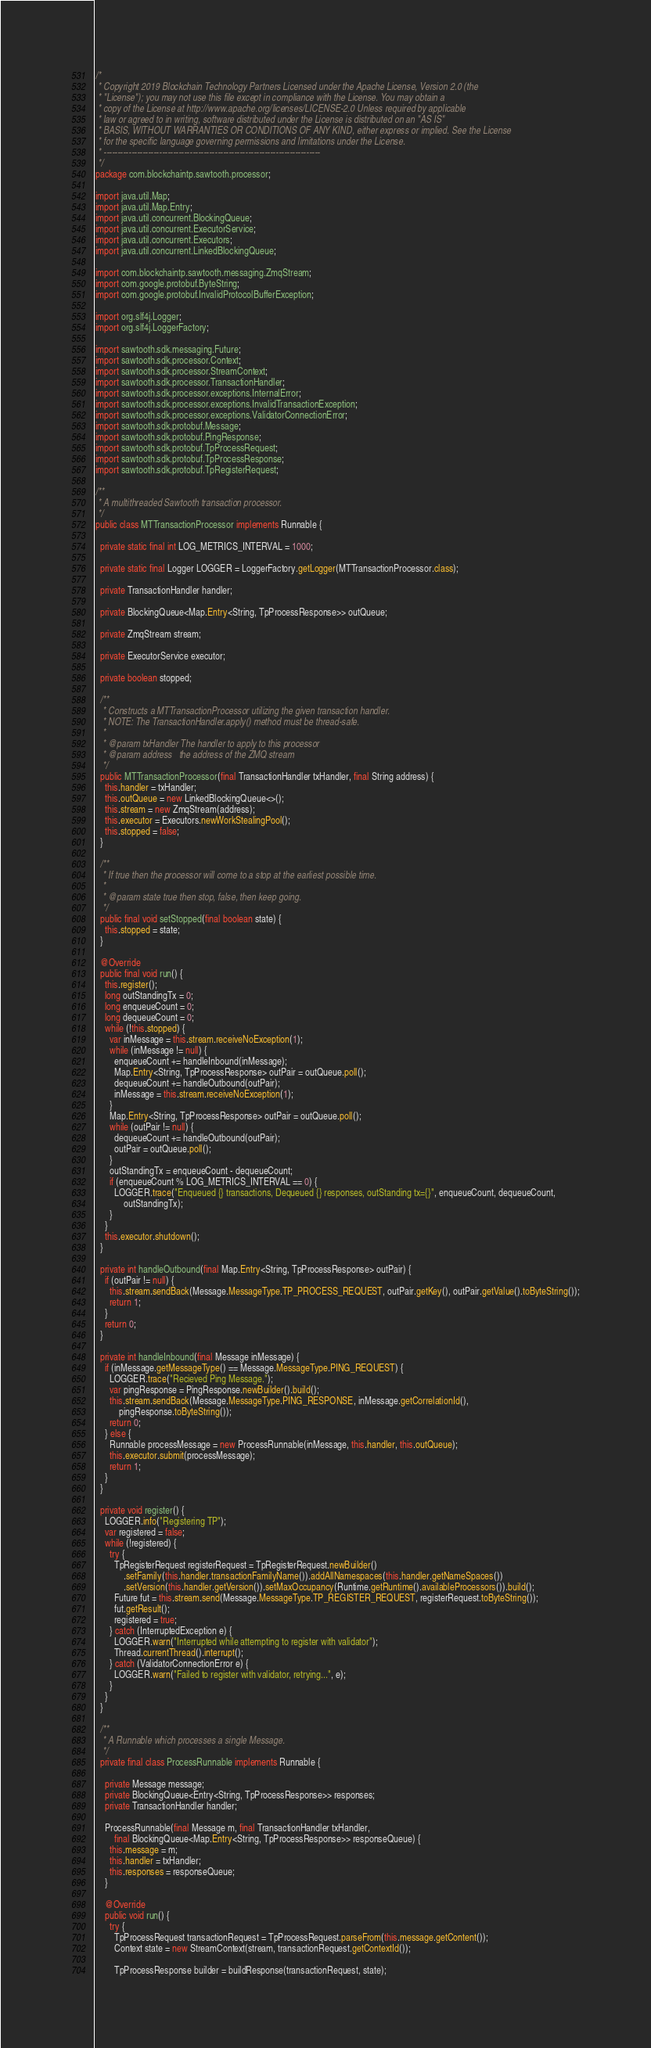<code> <loc_0><loc_0><loc_500><loc_500><_Java_>/*
 * Copyright 2019 Blockchain Technology Partners Licensed under the Apache License, Version 2.0 (the
 * "License"); you may not use this file except in compliance with the License. You may obtain a
 * copy of the License at http://www.apache.org/licenses/LICENSE-2.0 Unless required by applicable
 * law or agreed to in writing, software distributed under the License is distributed on an "AS IS"
 * BASIS, WITHOUT WARRANTIES OR CONDITIONS OF ANY KIND, either express or implied. See the License
 * for the specific language governing permissions and limitations under the License.
 * ------------------------------------------------------------------------------
 */
package com.blockchaintp.sawtooth.processor;

import java.util.Map;
import java.util.Map.Entry;
import java.util.concurrent.BlockingQueue;
import java.util.concurrent.ExecutorService;
import java.util.concurrent.Executors;
import java.util.concurrent.LinkedBlockingQueue;

import com.blockchaintp.sawtooth.messaging.ZmqStream;
import com.google.protobuf.ByteString;
import com.google.protobuf.InvalidProtocolBufferException;

import org.slf4j.Logger;
import org.slf4j.LoggerFactory;

import sawtooth.sdk.messaging.Future;
import sawtooth.sdk.processor.Context;
import sawtooth.sdk.processor.StreamContext;
import sawtooth.sdk.processor.TransactionHandler;
import sawtooth.sdk.processor.exceptions.InternalError;
import sawtooth.sdk.processor.exceptions.InvalidTransactionException;
import sawtooth.sdk.processor.exceptions.ValidatorConnectionError;
import sawtooth.sdk.protobuf.Message;
import sawtooth.sdk.protobuf.PingResponse;
import sawtooth.sdk.protobuf.TpProcessRequest;
import sawtooth.sdk.protobuf.TpProcessResponse;
import sawtooth.sdk.protobuf.TpRegisterRequest;

/**
 * A multithreaded Sawtooth transaction processor.
 */
public class MTTransactionProcessor implements Runnable {

  private static final int LOG_METRICS_INTERVAL = 1000;

  private static final Logger LOGGER = LoggerFactory.getLogger(MTTransactionProcessor.class);

  private TransactionHandler handler;

  private BlockingQueue<Map.Entry<String, TpProcessResponse>> outQueue;

  private ZmqStream stream;

  private ExecutorService executor;

  private boolean stopped;

  /**
   * Constructs a MTTransactionProcessor utilizing the given transaction handler.
   * NOTE: The TransactionHandler.apply() method must be thread-safe.
   *
   * @param txHandler The handler to apply to this processor
   * @param address   the address of the ZMQ stream
   */
  public MTTransactionProcessor(final TransactionHandler txHandler, final String address) {
    this.handler = txHandler;
    this.outQueue = new LinkedBlockingQueue<>();
    this.stream = new ZmqStream(address);
    this.executor = Executors.newWorkStealingPool();
    this.stopped = false;
  }

  /**
   * If true then the processor will come to a stop at the earliest possible time.
   *
   * @param state true then stop, false, then keep going.
   */
  public final void setStopped(final boolean state) {
    this.stopped = state;
  }

  @Override
  public final void run() {
    this.register();
    long outStandingTx = 0;
    long enqueueCount = 0;
    long dequeueCount = 0;
    while (!this.stopped) {
      var inMessage = this.stream.receiveNoException(1);
      while (inMessage != null) {
        enqueueCount += handleInbound(inMessage);
        Map.Entry<String, TpProcessResponse> outPair = outQueue.poll();
        dequeueCount += handleOutbound(outPair);
        inMessage = this.stream.receiveNoException(1);
      }
      Map.Entry<String, TpProcessResponse> outPair = outQueue.poll();
      while (outPair != null) {
        dequeueCount += handleOutbound(outPair);
        outPair = outQueue.poll();
      }
      outStandingTx = enqueueCount - dequeueCount;
      if (enqueueCount % LOG_METRICS_INTERVAL == 0) {
        LOGGER.trace("Enqueued {} transactions, Dequeued {} responses, outStanding tx={}", enqueueCount, dequeueCount,
            outStandingTx);
      }
    }
    this.executor.shutdown();
  }

  private int handleOutbound(final Map.Entry<String, TpProcessResponse> outPair) {
    if (outPair != null) {
      this.stream.sendBack(Message.MessageType.TP_PROCESS_REQUEST, outPair.getKey(), outPair.getValue().toByteString());
      return 1;
    }
    return 0;
  }

  private int handleInbound(final Message inMessage) {
    if (inMessage.getMessageType() == Message.MessageType.PING_REQUEST) {
      LOGGER.trace("Recieved Ping Message.");
      var pingResponse = PingResponse.newBuilder().build();
      this.stream.sendBack(Message.MessageType.PING_RESPONSE, inMessage.getCorrelationId(),
          pingResponse.toByteString());
      return 0;
    } else {
      Runnable processMessage = new ProcessRunnable(inMessage, this.handler, this.outQueue);
      this.executor.submit(processMessage);
      return 1;
    }
  }

  private void register() {
    LOGGER.info("Registering TP");
    var registered = false;
    while (!registered) {
      try {
        TpRegisterRequest registerRequest = TpRegisterRequest.newBuilder()
            .setFamily(this.handler.transactionFamilyName()).addAllNamespaces(this.handler.getNameSpaces())
            .setVersion(this.handler.getVersion()).setMaxOccupancy(Runtime.getRuntime().availableProcessors()).build();
        Future fut = this.stream.send(Message.MessageType.TP_REGISTER_REQUEST, registerRequest.toByteString());
        fut.getResult();
        registered = true;
      } catch (InterruptedException e) {
        LOGGER.warn("Interrupted while attempting to register with validator");
        Thread.currentThread().interrupt();
      } catch (ValidatorConnectionError e) {
        LOGGER.warn("Failed to register with validator, retrying...", e);
      }
    }
  }

  /**
   * A Runnable which processes a single Message.
   */
  private final class ProcessRunnable implements Runnable {

    private Message message;
    private BlockingQueue<Entry<String, TpProcessResponse>> responses;
    private TransactionHandler handler;

    ProcessRunnable(final Message m, final TransactionHandler txHandler,
        final BlockingQueue<Map.Entry<String, TpProcessResponse>> responseQueue) {
      this.message = m;
      this.handler = txHandler;
      this.responses = responseQueue;
    }

    @Override
    public void run() {
      try {
        TpProcessRequest transactionRequest = TpProcessRequest.parseFrom(this.message.getContent());
        Context state = new StreamContext(stream, transactionRequest.getContextId());

        TpProcessResponse builder = buildResponse(transactionRequest, state);</code> 